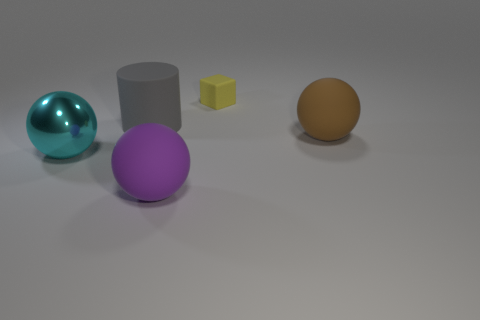Subtract all shiny spheres. How many spheres are left? 2 Add 2 gray blocks. How many objects exist? 7 Subtract all cylinders. How many objects are left? 4 Subtract all big shiny balls. Subtract all small yellow matte cubes. How many objects are left? 3 Add 1 cylinders. How many cylinders are left? 2 Add 1 tiny purple spheres. How many tiny purple spheres exist? 1 Subtract 0 brown blocks. How many objects are left? 5 